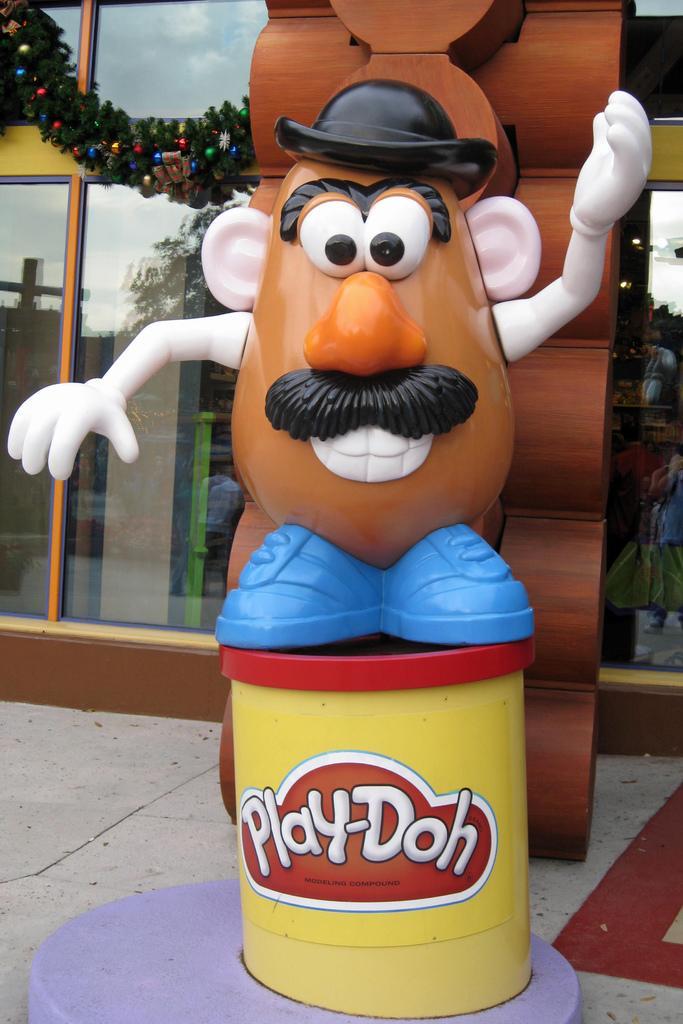Can you describe this image briefly? This picture shows a building and we see a cartoon toy on the sidewalk and we see decoration to the glass.. 